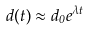Convert formula to latex. <formula><loc_0><loc_0><loc_500><loc_500>d ( t ) \approx { d _ { 0 } } { e } ^ { \lambda t }</formula> 